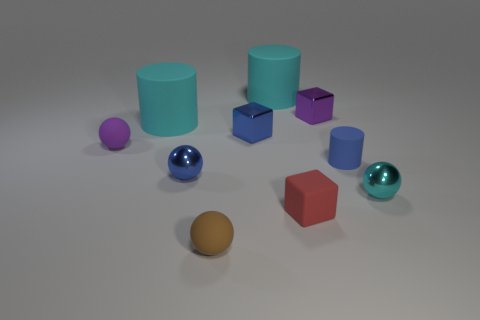Subtract 1 spheres. How many spheres are left? 3 Subtract all cylinders. How many objects are left? 7 Subtract 0 red cylinders. How many objects are left? 10 Subtract all brown rubber balls. Subtract all tiny red matte spheres. How many objects are left? 9 Add 7 matte cubes. How many matte cubes are left? 8 Add 7 purple matte spheres. How many purple matte spheres exist? 8 